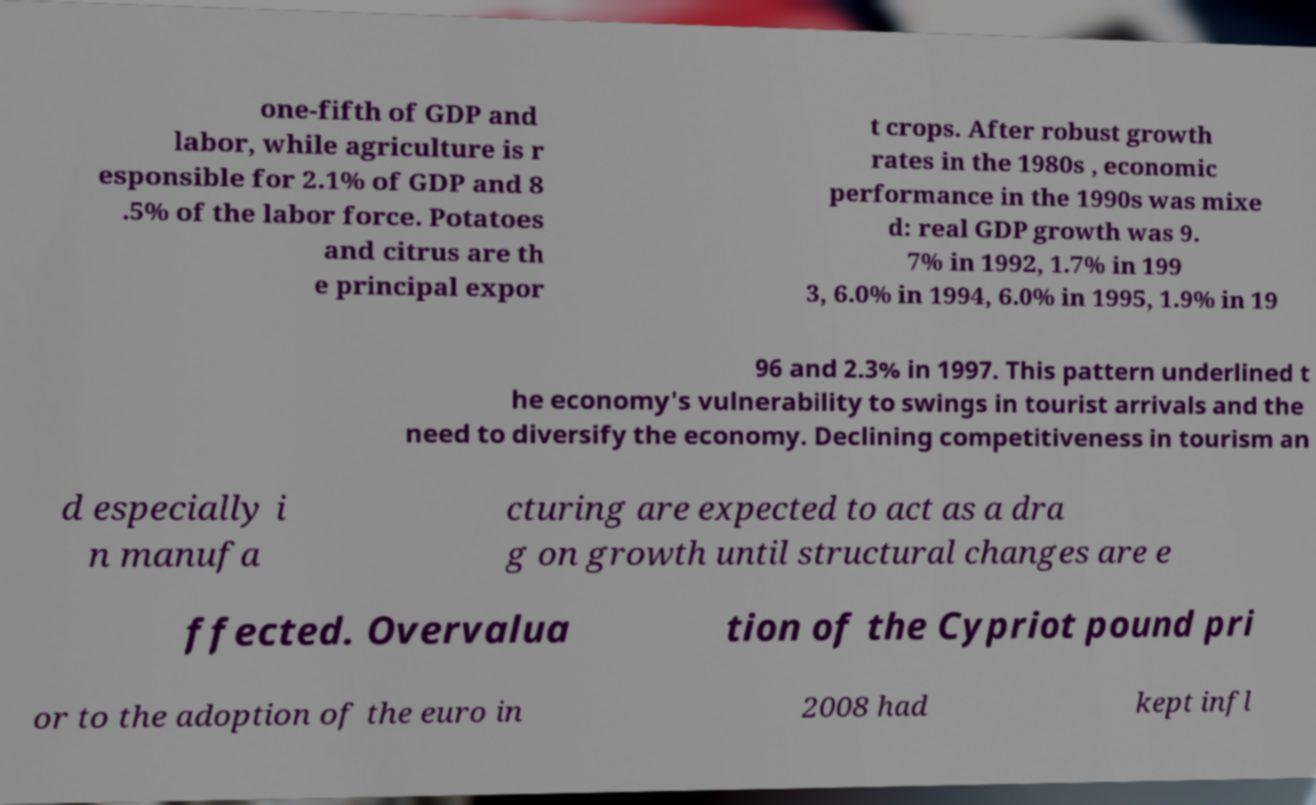Please identify and transcribe the text found in this image. one-fifth of GDP and labor, while agriculture is r esponsible for 2.1% of GDP and 8 .5% of the labor force. Potatoes and citrus are th e principal expor t crops. After robust growth rates in the 1980s , economic performance in the 1990s was mixe d: real GDP growth was 9. 7% in 1992, 1.7% in 199 3, 6.0% in 1994, 6.0% in 1995, 1.9% in 19 96 and 2.3% in 1997. This pattern underlined t he economy's vulnerability to swings in tourist arrivals and the need to diversify the economy. Declining competitiveness in tourism an d especially i n manufa cturing are expected to act as a dra g on growth until structural changes are e ffected. Overvalua tion of the Cypriot pound pri or to the adoption of the euro in 2008 had kept infl 